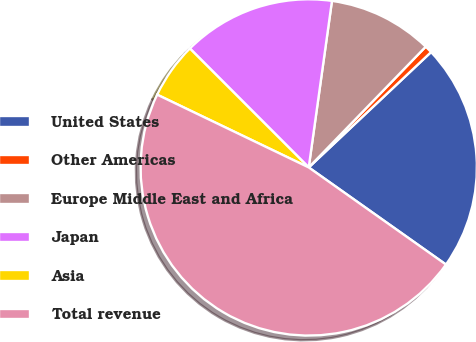<chart> <loc_0><loc_0><loc_500><loc_500><pie_chart><fcel>United States<fcel>Other Americas<fcel>Europe Middle East and Africa<fcel>Japan<fcel>Asia<fcel>Total revenue<nl><fcel>21.83%<fcel>0.72%<fcel>10.04%<fcel>14.7%<fcel>5.38%<fcel>47.32%<nl></chart> 